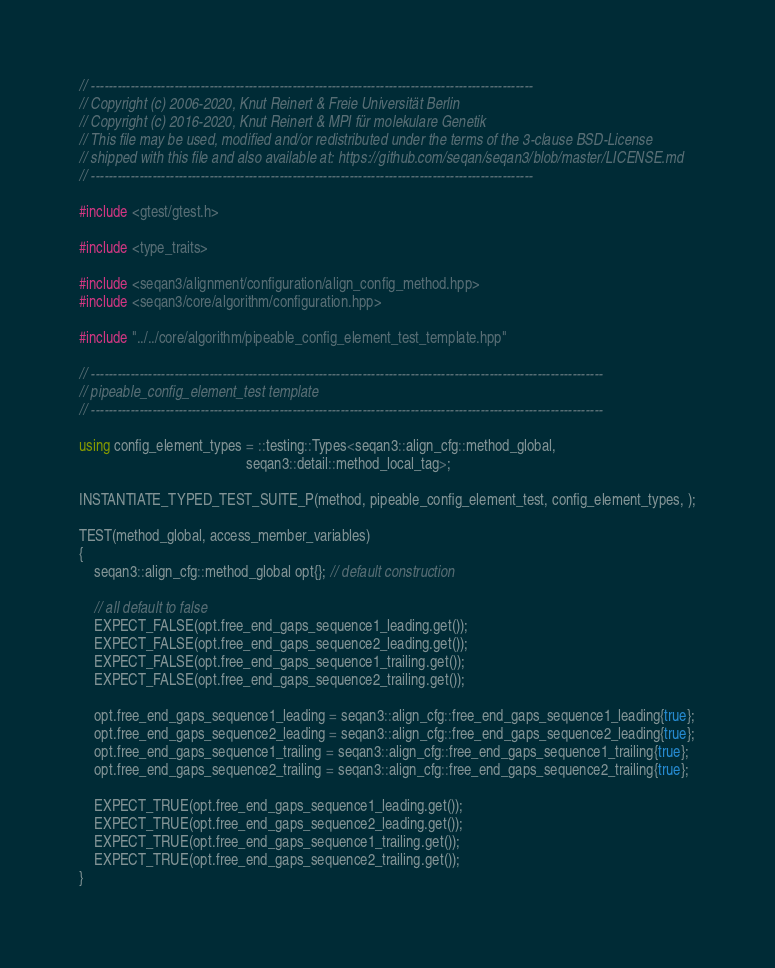Convert code to text. <code><loc_0><loc_0><loc_500><loc_500><_C++_>// -----------------------------------------------------------------------------------------------------
// Copyright (c) 2006-2020, Knut Reinert & Freie Universität Berlin
// Copyright (c) 2016-2020, Knut Reinert & MPI für molekulare Genetik
// This file may be used, modified and/or redistributed under the terms of the 3-clause BSD-License
// shipped with this file and also available at: https://github.com/seqan/seqan3/blob/master/LICENSE.md
// -----------------------------------------------------------------------------------------------------

#include <gtest/gtest.h>

#include <type_traits>

#include <seqan3/alignment/configuration/align_config_method.hpp>
#include <seqan3/core/algorithm/configuration.hpp>

#include "../../core/algorithm/pipeable_config_element_test_template.hpp"

// ---------------------------------------------------------------------------------------------------------------------
// pipeable_config_element_test template
// ---------------------------------------------------------------------------------------------------------------------

using config_element_types = ::testing::Types<seqan3::align_cfg::method_global,
                                              seqan3::detail::method_local_tag>;

INSTANTIATE_TYPED_TEST_SUITE_P(method, pipeable_config_element_test, config_element_types, );

TEST(method_global, access_member_variables)
{
    seqan3::align_cfg::method_global opt{}; // default construction

    // all default to false
    EXPECT_FALSE(opt.free_end_gaps_sequence1_leading.get());
    EXPECT_FALSE(opt.free_end_gaps_sequence2_leading.get());
    EXPECT_FALSE(opt.free_end_gaps_sequence1_trailing.get());
    EXPECT_FALSE(opt.free_end_gaps_sequence2_trailing.get());

    opt.free_end_gaps_sequence1_leading = seqan3::align_cfg::free_end_gaps_sequence1_leading{true};
    opt.free_end_gaps_sequence2_leading = seqan3::align_cfg::free_end_gaps_sequence2_leading{true};
    opt.free_end_gaps_sequence1_trailing = seqan3::align_cfg::free_end_gaps_sequence1_trailing{true};
    opt.free_end_gaps_sequence2_trailing = seqan3::align_cfg::free_end_gaps_sequence2_trailing{true};

    EXPECT_TRUE(opt.free_end_gaps_sequence1_leading.get());
    EXPECT_TRUE(opt.free_end_gaps_sequence2_leading.get());
    EXPECT_TRUE(opt.free_end_gaps_sequence1_trailing.get());
    EXPECT_TRUE(opt.free_end_gaps_sequence2_trailing.get());
}
</code> 